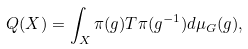Convert formula to latex. <formula><loc_0><loc_0><loc_500><loc_500>Q ( X ) = \int _ { X } \pi ( g ) T \pi ( g ^ { - 1 } ) d \mu _ { G } ( g ) ,</formula> 